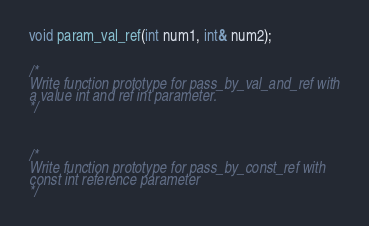Convert code to text. <code><loc_0><loc_0><loc_500><loc_500><_C_>void param_val_ref(int num1, int& num2);


/*
Write function prototype for pass_by_val_and_ref with
a value int and ref int parameter.
*/



/*
Write function prototype for pass_by_const_ref with
const int reference parameter
*/
</code> 